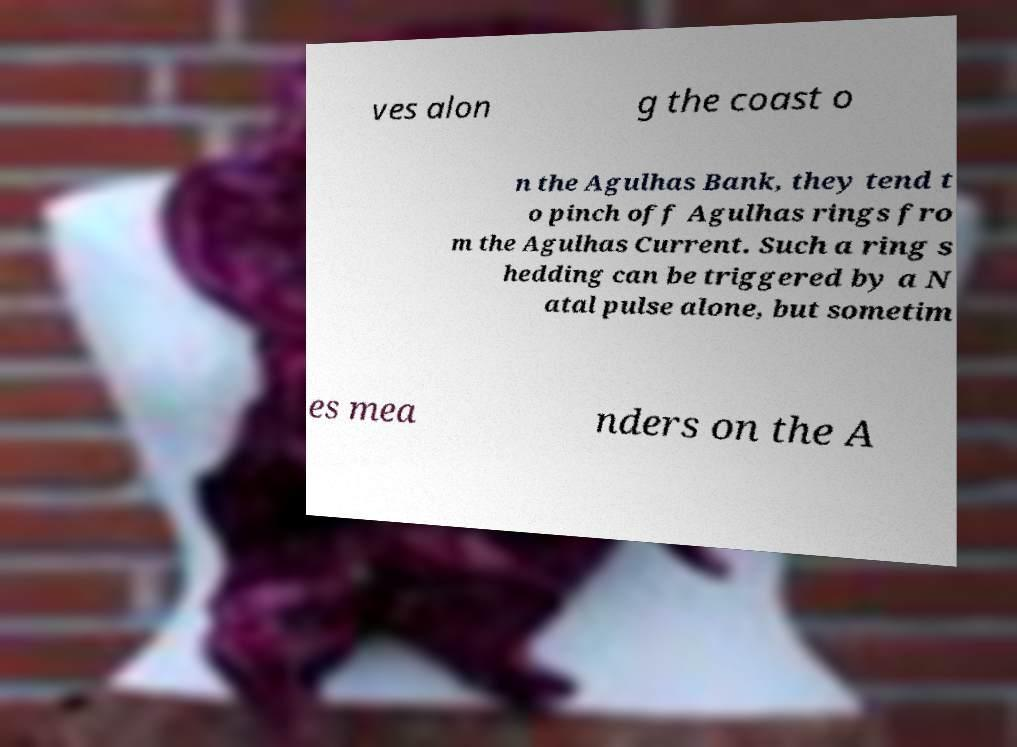Please identify and transcribe the text found in this image. ves alon g the coast o n the Agulhas Bank, they tend t o pinch off Agulhas rings fro m the Agulhas Current. Such a ring s hedding can be triggered by a N atal pulse alone, but sometim es mea nders on the A 